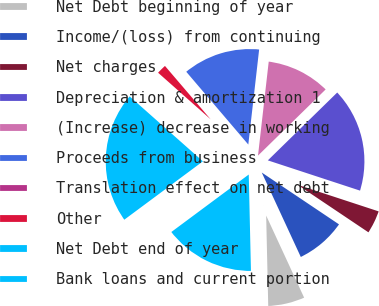<chart> <loc_0><loc_0><loc_500><loc_500><pie_chart><fcel>Net Debt beginning of year<fcel>Income/(loss) from continuing<fcel>Net charges<fcel>Depreciation & amortization 1<fcel>(Increase) decrease in working<fcel>Proceeds from business<fcel>Translation effect on net debt<fcel>Other<fcel>Net Debt end of year<fcel>Bank loans and current portion<nl><fcel>6.53%<fcel>8.7%<fcel>4.36%<fcel>17.37%<fcel>10.87%<fcel>13.04%<fcel>0.03%<fcel>2.19%<fcel>21.71%<fcel>15.2%<nl></chart> 